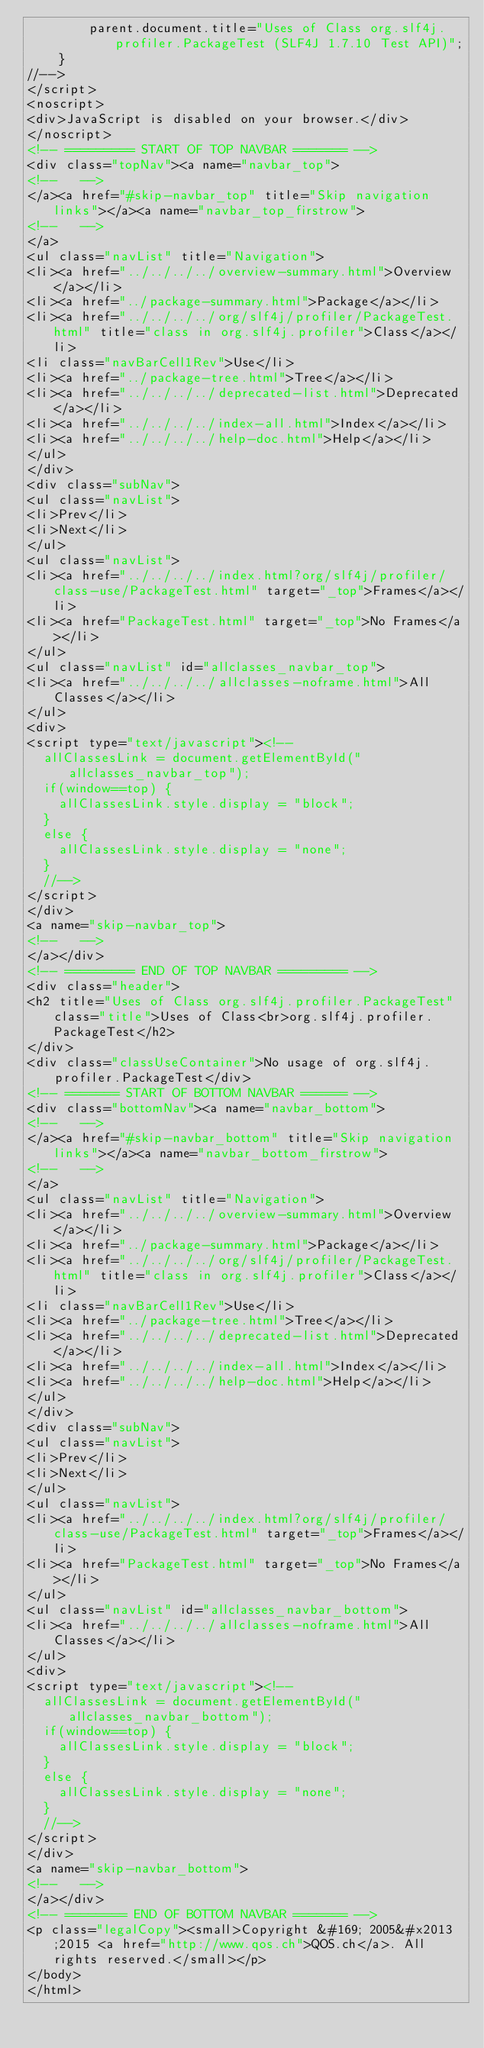Convert code to text. <code><loc_0><loc_0><loc_500><loc_500><_HTML_>        parent.document.title="Uses of Class org.slf4j.profiler.PackageTest (SLF4J 1.7.10 Test API)";
    }
//-->
</script>
<noscript>
<div>JavaScript is disabled on your browser.</div>
</noscript>
<!-- ========= START OF TOP NAVBAR ======= -->
<div class="topNav"><a name="navbar_top">
<!--   -->
</a><a href="#skip-navbar_top" title="Skip navigation links"></a><a name="navbar_top_firstrow">
<!--   -->
</a>
<ul class="navList" title="Navigation">
<li><a href="../../../../overview-summary.html">Overview</a></li>
<li><a href="../package-summary.html">Package</a></li>
<li><a href="../../../../org/slf4j/profiler/PackageTest.html" title="class in org.slf4j.profiler">Class</a></li>
<li class="navBarCell1Rev">Use</li>
<li><a href="../package-tree.html">Tree</a></li>
<li><a href="../../../../deprecated-list.html">Deprecated</a></li>
<li><a href="../../../../index-all.html">Index</a></li>
<li><a href="../../../../help-doc.html">Help</a></li>
</ul>
</div>
<div class="subNav">
<ul class="navList">
<li>Prev</li>
<li>Next</li>
</ul>
<ul class="navList">
<li><a href="../../../../index.html?org/slf4j/profiler/class-use/PackageTest.html" target="_top">Frames</a></li>
<li><a href="PackageTest.html" target="_top">No Frames</a></li>
</ul>
<ul class="navList" id="allclasses_navbar_top">
<li><a href="../../../../allclasses-noframe.html">All Classes</a></li>
</ul>
<div>
<script type="text/javascript"><!--
  allClassesLink = document.getElementById("allclasses_navbar_top");
  if(window==top) {
    allClassesLink.style.display = "block";
  }
  else {
    allClassesLink.style.display = "none";
  }
  //-->
</script>
</div>
<a name="skip-navbar_top">
<!--   -->
</a></div>
<!-- ========= END OF TOP NAVBAR ========= -->
<div class="header">
<h2 title="Uses of Class org.slf4j.profiler.PackageTest" class="title">Uses of Class<br>org.slf4j.profiler.PackageTest</h2>
</div>
<div class="classUseContainer">No usage of org.slf4j.profiler.PackageTest</div>
<!-- ======= START OF BOTTOM NAVBAR ====== -->
<div class="bottomNav"><a name="navbar_bottom">
<!--   -->
</a><a href="#skip-navbar_bottom" title="Skip navigation links"></a><a name="navbar_bottom_firstrow">
<!--   -->
</a>
<ul class="navList" title="Navigation">
<li><a href="../../../../overview-summary.html">Overview</a></li>
<li><a href="../package-summary.html">Package</a></li>
<li><a href="../../../../org/slf4j/profiler/PackageTest.html" title="class in org.slf4j.profiler">Class</a></li>
<li class="navBarCell1Rev">Use</li>
<li><a href="../package-tree.html">Tree</a></li>
<li><a href="../../../../deprecated-list.html">Deprecated</a></li>
<li><a href="../../../../index-all.html">Index</a></li>
<li><a href="../../../../help-doc.html">Help</a></li>
</ul>
</div>
<div class="subNav">
<ul class="navList">
<li>Prev</li>
<li>Next</li>
</ul>
<ul class="navList">
<li><a href="../../../../index.html?org/slf4j/profiler/class-use/PackageTest.html" target="_top">Frames</a></li>
<li><a href="PackageTest.html" target="_top">No Frames</a></li>
</ul>
<ul class="navList" id="allclasses_navbar_bottom">
<li><a href="../../../../allclasses-noframe.html">All Classes</a></li>
</ul>
<div>
<script type="text/javascript"><!--
  allClassesLink = document.getElementById("allclasses_navbar_bottom");
  if(window==top) {
    allClassesLink.style.display = "block";
  }
  else {
    allClassesLink.style.display = "none";
  }
  //-->
</script>
</div>
<a name="skip-navbar_bottom">
<!--   -->
</a></div>
<!-- ======== END OF BOTTOM NAVBAR ======= -->
<p class="legalCopy"><small>Copyright &#169; 2005&#x2013;2015 <a href="http://www.qos.ch">QOS.ch</a>. All rights reserved.</small></p>
</body>
</html>
</code> 